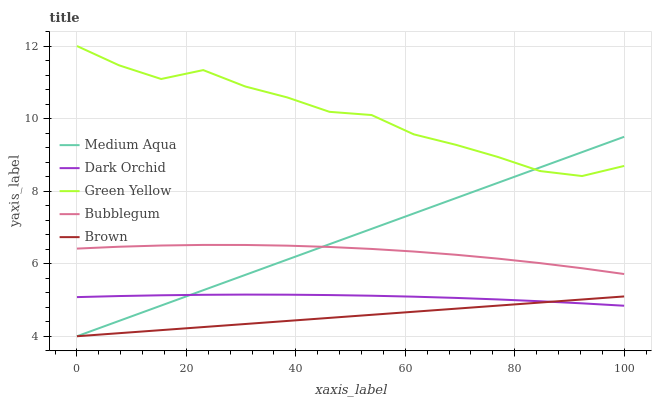Does Brown have the minimum area under the curve?
Answer yes or no. Yes. Does Green Yellow have the maximum area under the curve?
Answer yes or no. Yes. Does Medium Aqua have the minimum area under the curve?
Answer yes or no. No. Does Medium Aqua have the maximum area under the curve?
Answer yes or no. No. Is Brown the smoothest?
Answer yes or no. Yes. Is Green Yellow the roughest?
Answer yes or no. Yes. Is Medium Aqua the smoothest?
Answer yes or no. No. Is Medium Aqua the roughest?
Answer yes or no. No. Does Brown have the lowest value?
Answer yes or no. Yes. Does Green Yellow have the lowest value?
Answer yes or no. No. Does Green Yellow have the highest value?
Answer yes or no. Yes. Does Medium Aqua have the highest value?
Answer yes or no. No. Is Bubblegum less than Green Yellow?
Answer yes or no. Yes. Is Bubblegum greater than Brown?
Answer yes or no. Yes. Does Medium Aqua intersect Bubblegum?
Answer yes or no. Yes. Is Medium Aqua less than Bubblegum?
Answer yes or no. No. Is Medium Aqua greater than Bubblegum?
Answer yes or no. No. Does Bubblegum intersect Green Yellow?
Answer yes or no. No. 